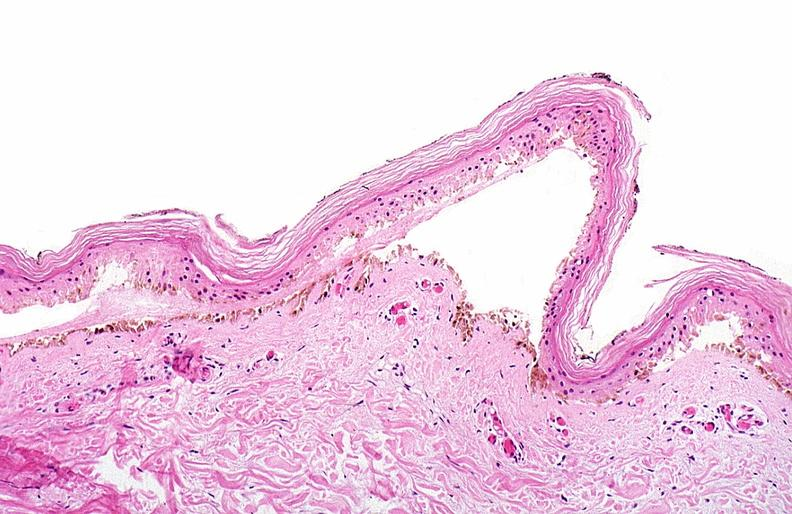does this image show thermal burned skin?
Answer the question using a single word or phrase. Yes 